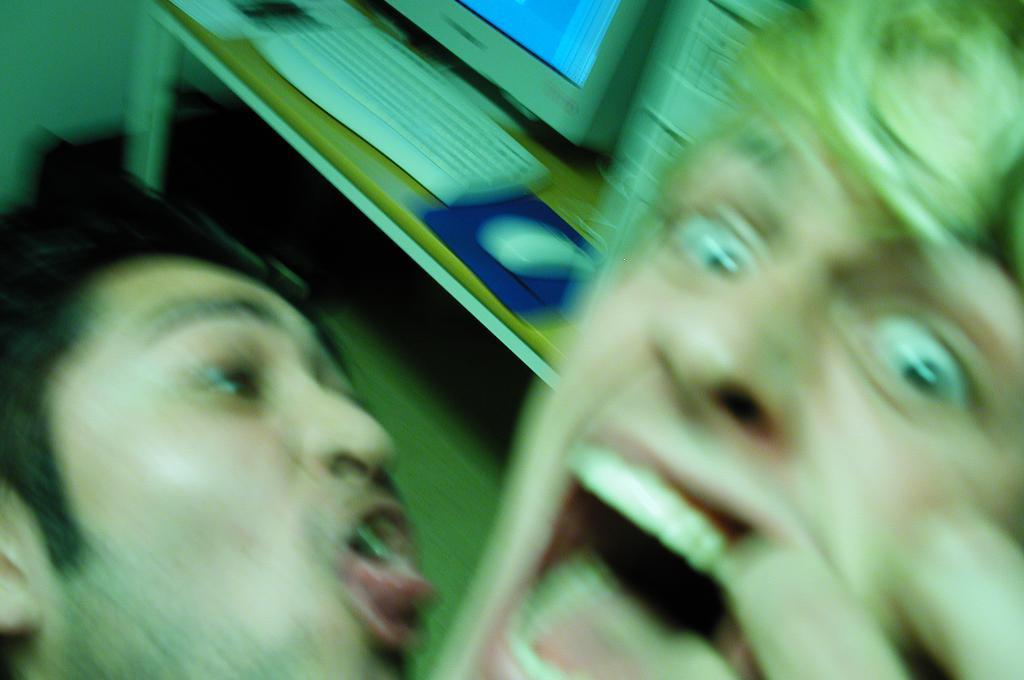How many people are present in the image? There are two people in the image. Can you describe the faces of the people in the image? The faces of the two people are visible in the image. What can be seen in the background of the image? There is a system visible in the background of the image. Can you hear the frog croaking in the image? There is no frog present in the image, so it is not possible to hear it croaking. 